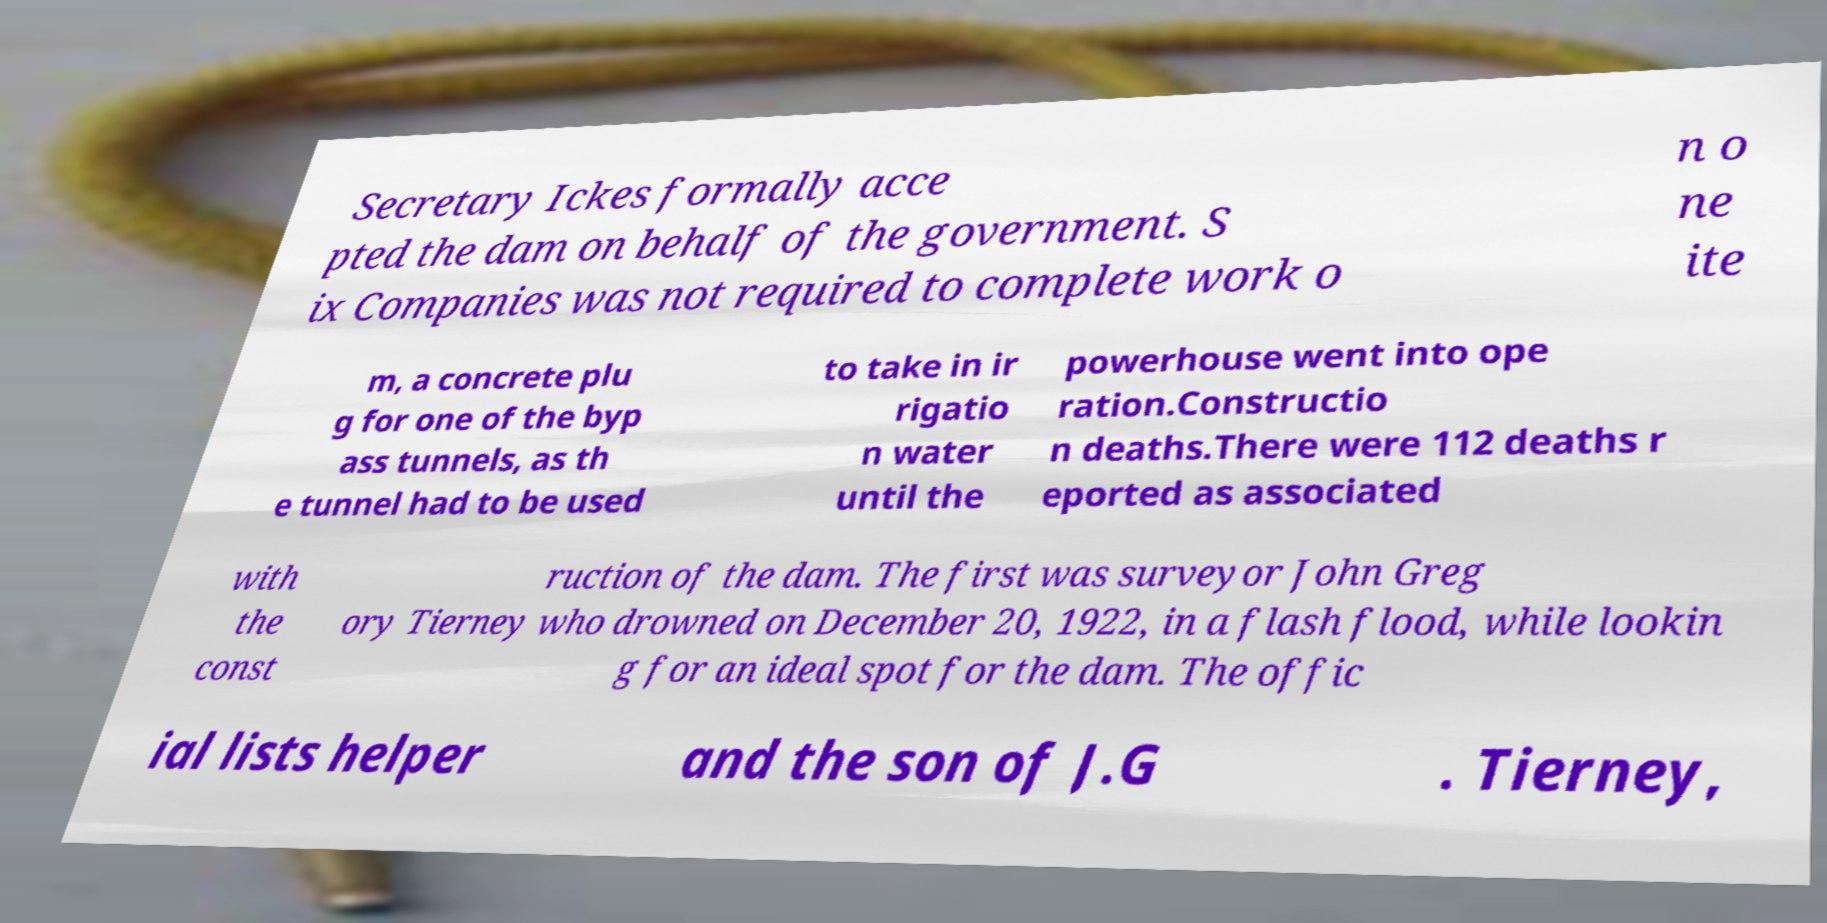Please identify and transcribe the text found in this image. Secretary Ickes formally acce pted the dam on behalf of the government. S ix Companies was not required to complete work o n o ne ite m, a concrete plu g for one of the byp ass tunnels, as th e tunnel had to be used to take in ir rigatio n water until the powerhouse went into ope ration.Constructio n deaths.There were 112 deaths r eported as associated with the const ruction of the dam. The first was surveyor John Greg ory Tierney who drowned on December 20, 1922, in a flash flood, while lookin g for an ideal spot for the dam. The offic ial lists helper and the son of J.G . Tierney, 